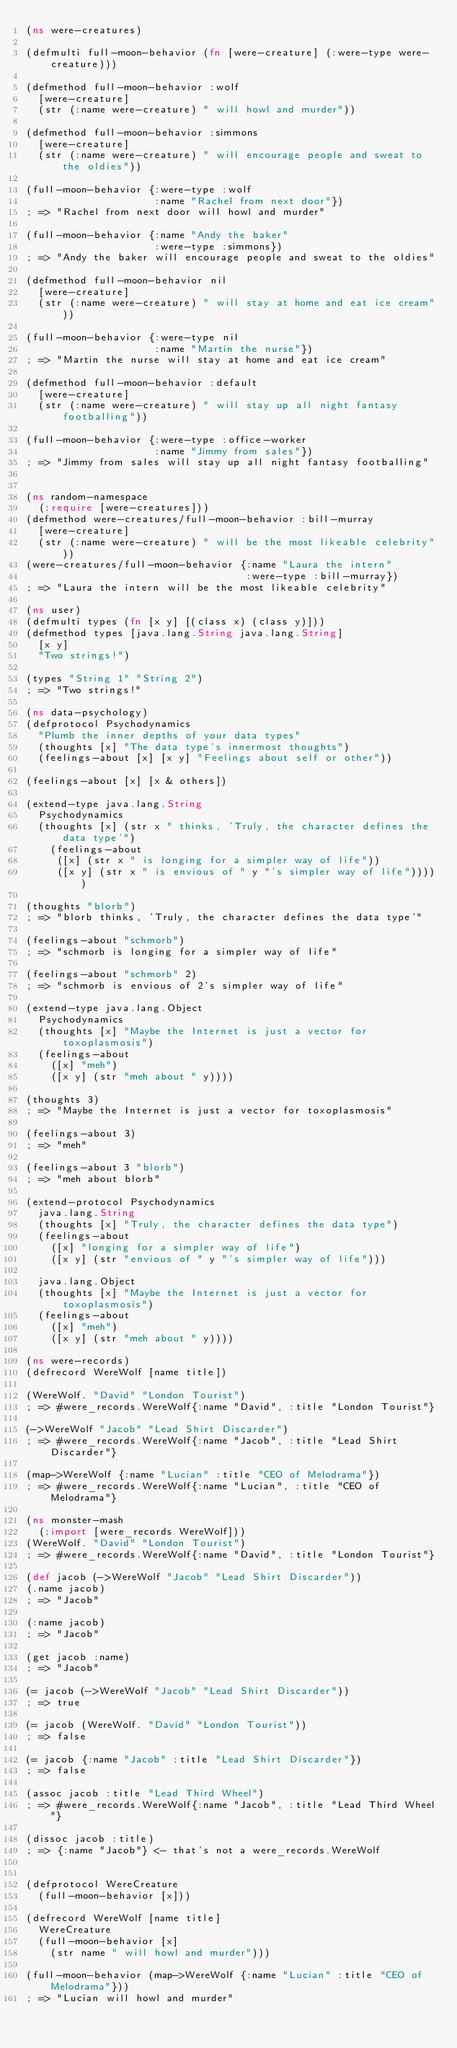Convert code to text. <code><loc_0><loc_0><loc_500><loc_500><_Clojure_>(ns were-creatures)

(defmulti full-moon-behavior (fn [were-creature] (:were-type were-creature)))

(defmethod full-moon-behavior :wolf
  [were-creature]
  (str (:name were-creature) " will howl and murder"))

(defmethod full-moon-behavior :simmons
  [were-creature]
  (str (:name were-creature) " will encourage people and sweat to the oldies"))

(full-moon-behavior {:were-type :wolf
                     :name "Rachel from next door"})
; => "Rachel from next door will howl and murder"

(full-moon-behavior {:name "Andy the baker"
                     :were-type :simmons})
; => "Andy the baker will encourage people and sweat to the oldies"

(defmethod full-moon-behavior nil
  [were-creature]
  (str (:name were-creature) " will stay at home and eat ice cream"))

(full-moon-behavior {:were-type nil
                     :name "Martin the nurse"})
; => "Martin the nurse will stay at home and eat ice cream"

(defmethod full-moon-behavior :default
  [were-creature]
  (str (:name were-creature) " will stay up all night fantasy footballing"))

(full-moon-behavior {:were-type :office-worker
                     :name "Jimmy from sales"})
; => "Jimmy from sales will stay up all night fantasy footballing"


(ns random-namespace
  (:require [were-creatures]))
(defmethod were-creatures/full-moon-behavior :bill-murray
  [were-creature]
  (str (:name were-creature) " will be the most likeable celebrity"))
(were-creatures/full-moon-behavior {:name "Laura the intern" 
                                    :were-type :bill-murray})
; => "Laura the intern will be the most likeable celebrity"

(ns user)
(defmulti types (fn [x y] [(class x) (class y)]))
(defmethod types [java.lang.String java.lang.String]
  [x y]
  "Two strings!")

(types "String 1" "String 2")
; => "Two strings!"

(ns data-psychology)
(defprotocol Psychodynamics
  "Plumb the inner depths of your data types"
  (thoughts [x] "The data type's innermost thoughts")
  (feelings-about [x] [x y] "Feelings about self or other"))

(feelings-about [x] [x & others])

(extend-type java.lang.String
  Psychodynamics
  (thoughts [x] (str x " thinks, 'Truly, the character defines the data type'")
    (feelings-about
     ([x] (str x " is longing for a simpler way of life"))
     ([x y] (str x " is envious of " y "'s simpler way of life")))))

(thoughts "blorb")
; => "blorb thinks, 'Truly, the character defines the data type'"

(feelings-about "schmorb")
; => "schmorb is longing for a simpler way of life"

(feelings-about "schmorb" 2)
; => "schmorb is envious of 2's simpler way of life"

(extend-type java.lang.Object
  Psychodynamics
  (thoughts [x] "Maybe the Internet is just a vector for toxoplasmosis")
  (feelings-about
    ([x] "meh")
    ([x y] (str "meh about " y))))

(thoughts 3)
; => "Maybe the Internet is just a vector for toxoplasmosis"

(feelings-about 3)
; => "meh"

(feelings-about 3 "blorb")
; => "meh about blorb"

(extend-protocol Psychodynamics
  java.lang.String
  (thoughts [x] "Truly, the character defines the data type")
  (feelings-about
    ([x] "longing for a simpler way of life")
    ([x y] (str "envious of " y "'s simpler way of life")))
  
  java.lang.Object
  (thoughts [x] "Maybe the Internet is just a vector for toxoplasmosis")
  (feelings-about
    ([x] "meh")
    ([x y] (str "meh about " y))))

(ns were-records)
(defrecord WereWolf [name title])

(WereWolf. "David" "London Tourist")
; => #were_records.WereWolf{:name "David", :title "London Tourist"}

(->WereWolf "Jacob" "Lead Shirt Discarder")
; => #were_records.WereWolf{:name "Jacob", :title "Lead Shirt Discarder"}

(map->WereWolf {:name "Lucian" :title "CEO of Melodrama"})
; => #were_records.WereWolf{:name "Lucian", :title "CEO of Melodrama"}

(ns monster-mash
  (:import [were_records WereWolf]))
(WereWolf. "David" "London Tourist")
; => #were_records.WereWolf{:name "David", :title "London Tourist"}

(def jacob (->WereWolf "Jacob" "Lead Shirt Discarder"))
(.name jacob) 
; => "Jacob"

(:name jacob) 
; => "Jacob"

(get jacob :name) 
; => "Jacob"

(= jacob (->WereWolf "Jacob" "Lead Shirt Discarder"))
; => true

(= jacob (WereWolf. "David" "London Tourist"))
; => false

(= jacob {:name "Jacob" :title "Lead Shirt Discarder"})
; => false

(assoc jacob :title "Lead Third Wheel")
; => #were_records.WereWolf{:name "Jacob", :title "Lead Third Wheel"}

(dissoc jacob :title)
; => {:name "Jacob"} <- that's not a were_records.WereWolf


(defprotocol WereCreature
  (full-moon-behavior [x]))

(defrecord WereWolf [name title]
  WereCreature
  (full-moon-behavior [x]
    (str name " will howl and murder")))

(full-moon-behavior (map->WereWolf {:name "Lucian" :title "CEO of Melodrama"}))
; => "Lucian will howl and murder"
</code> 